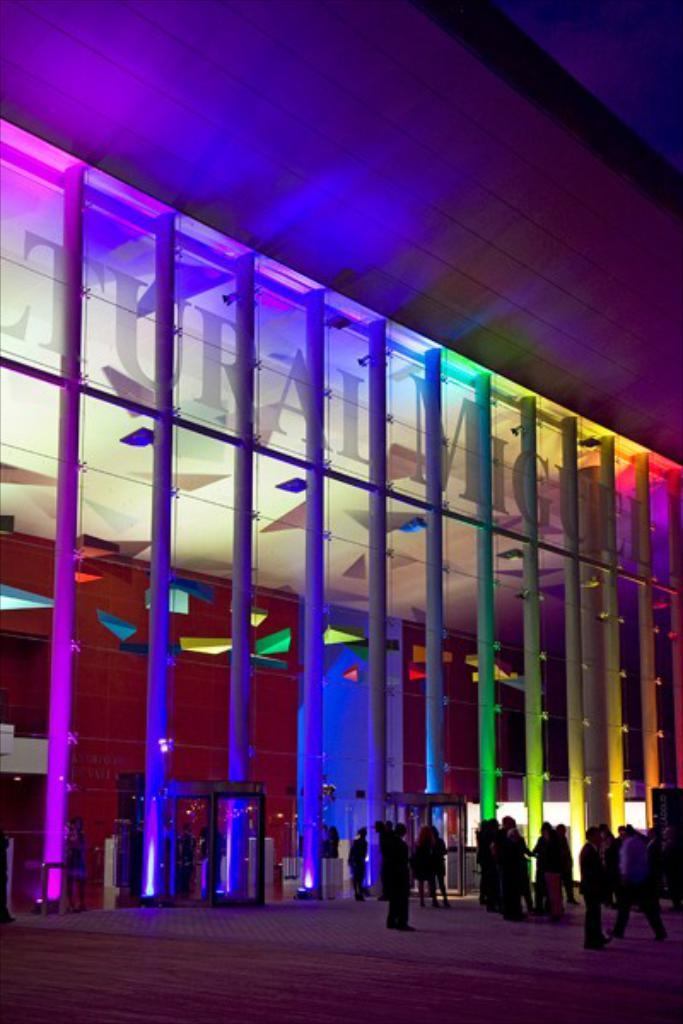What type of structure is present in the image? There is a building in the image. Can you describe the people at the bottom of the image? There are people at the bottom of the image. What architectural feature can be seen in the image? There are pillars visible in the image. What type of illumination is present in the image? There are lights in the image. What is the taste of the paper in the image? There is no paper present in the image, so it is not possible to determine its taste. 